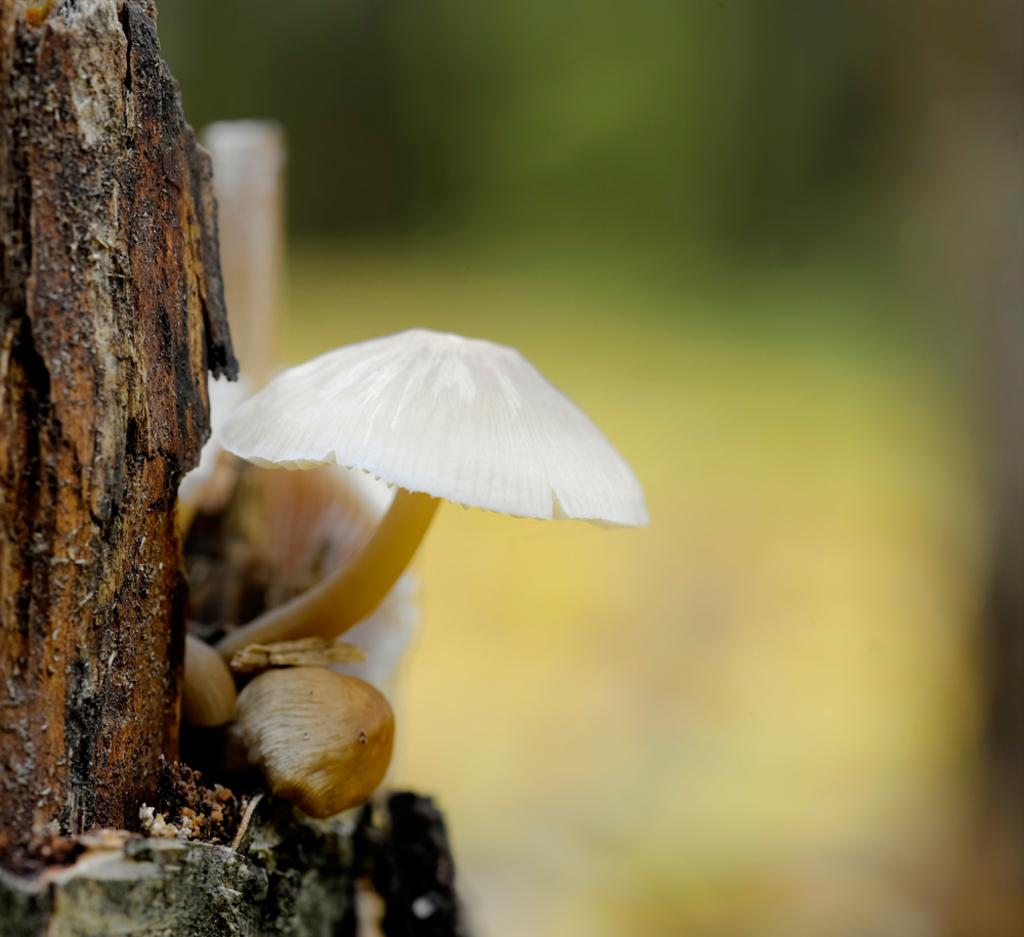What is the main subject of the image? There is a mushroom in the image. Where is the mushroom located? The mushroom is on a wooden trunk. Can you describe the background of the image? The background of the image is blurred. What type of berry can be seen growing on the mushroom in the image? There are no berries present on the mushroom in the image. What letters can be seen on the mushroom in the image? There are no letters present on the mushroom in the image. 